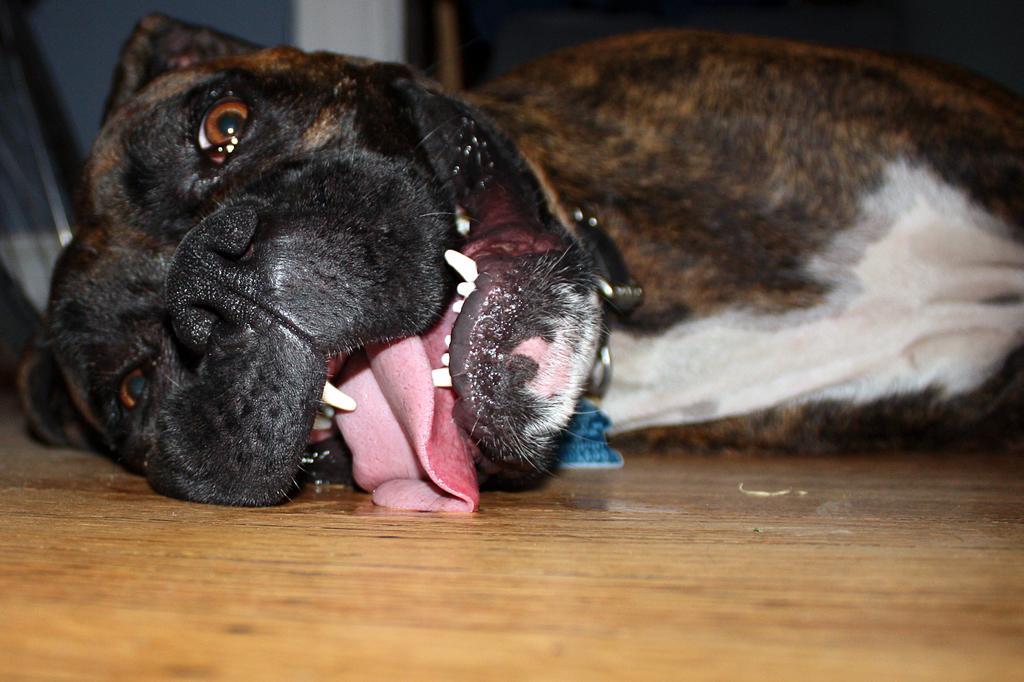Please provide a concise description of this image. In this image there is a dog sleeping on the floor. 